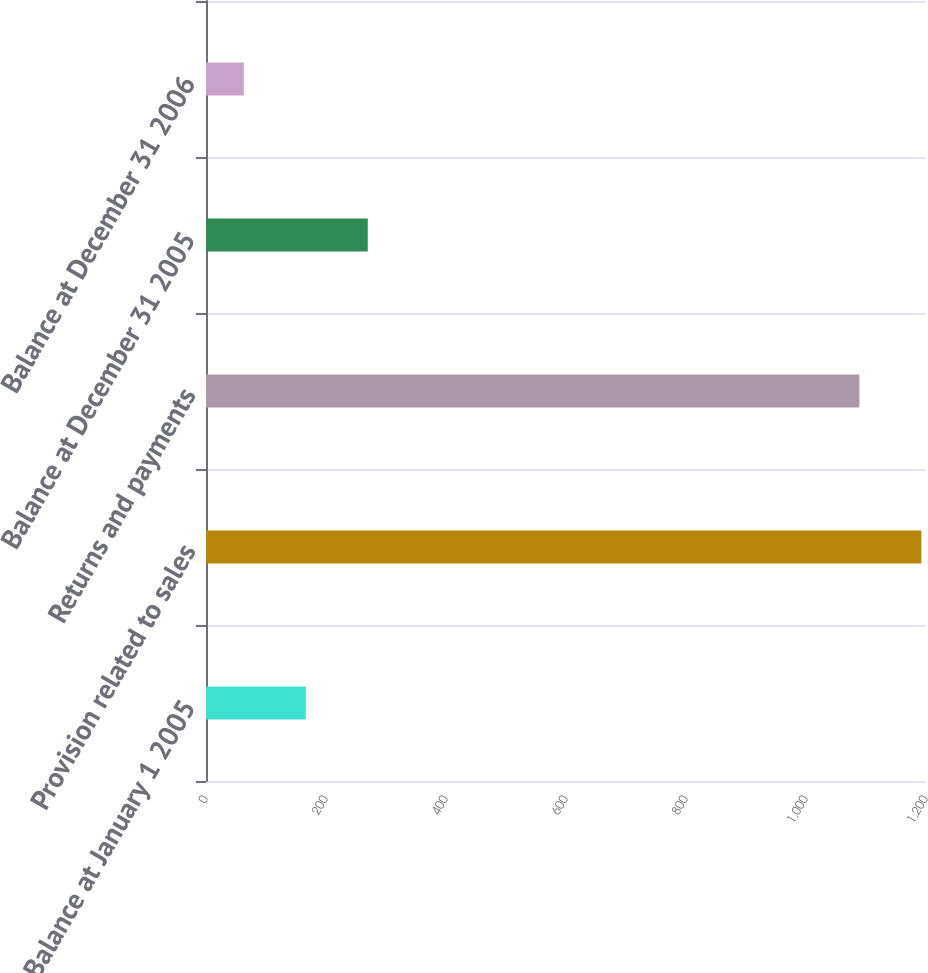<chart> <loc_0><loc_0><loc_500><loc_500><bar_chart><fcel>Balance at January 1 2005<fcel>Provision related to sales<fcel>Returns and payments<fcel>Balance at December 31 2005<fcel>Balance at December 31 2006<nl><fcel>166.3<fcel>1192.3<fcel>1089<fcel>269.6<fcel>63<nl></chart> 